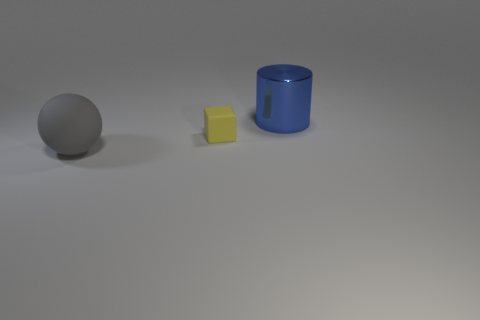Are there any other things that have the same size as the yellow block?
Offer a very short reply. No. Is there any other thing that is the same shape as the small yellow object?
Your response must be concise. No. Do the large object that is behind the yellow object and the large object that is in front of the blue thing have the same shape?
Your answer should be very brief. No. There is a yellow matte thing; is it the same size as the matte object on the left side of the cube?
Your answer should be very brief. No. Are there more cubes than green shiny cylinders?
Provide a succinct answer. Yes. Is the material of the large object that is on the left side of the cylinder the same as the object that is behind the tiny object?
Your answer should be compact. No. What is the gray ball made of?
Offer a terse response. Rubber. Is the number of large things that are in front of the tiny cube greater than the number of matte objects?
Offer a very short reply. No. How many yellow rubber things are to the right of the big thing in front of the large object right of the small thing?
Make the answer very short. 1. The tiny thing is what color?
Provide a succinct answer. Yellow. 